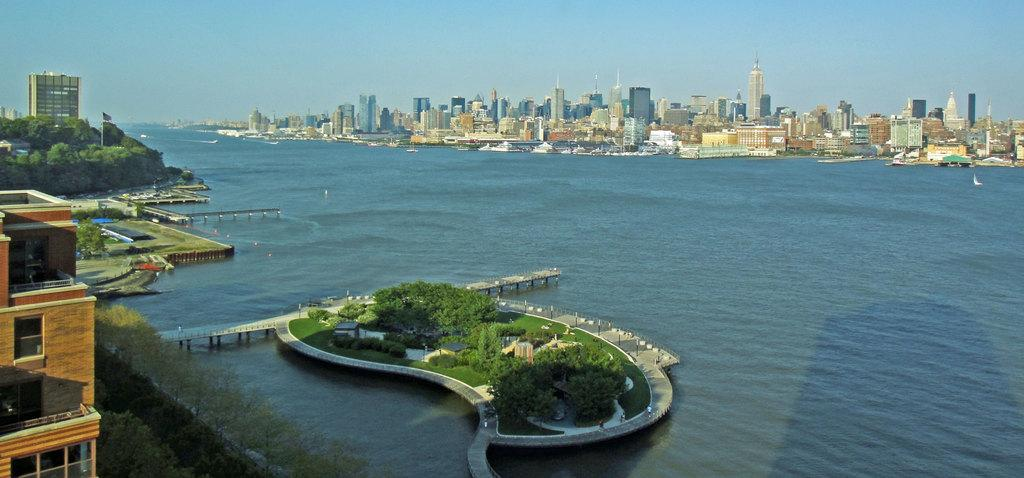What is present in the image that represents a body of water? There is water in the image. What structure can be seen crossing over the water? There is a bridge in the image. What can be found on the left side of the image? There are buildings and trees on the left side of the image. What is visible in the background of the image? There are many buildings in the background of the image. What part of the natural environment is visible in the image? The sky is visible in the image. Where is the desk located in the image? There is no desk present in the image. Can you describe how the buildings in the background are turning? The buildings in the background are not turning; they are stationary structures. 